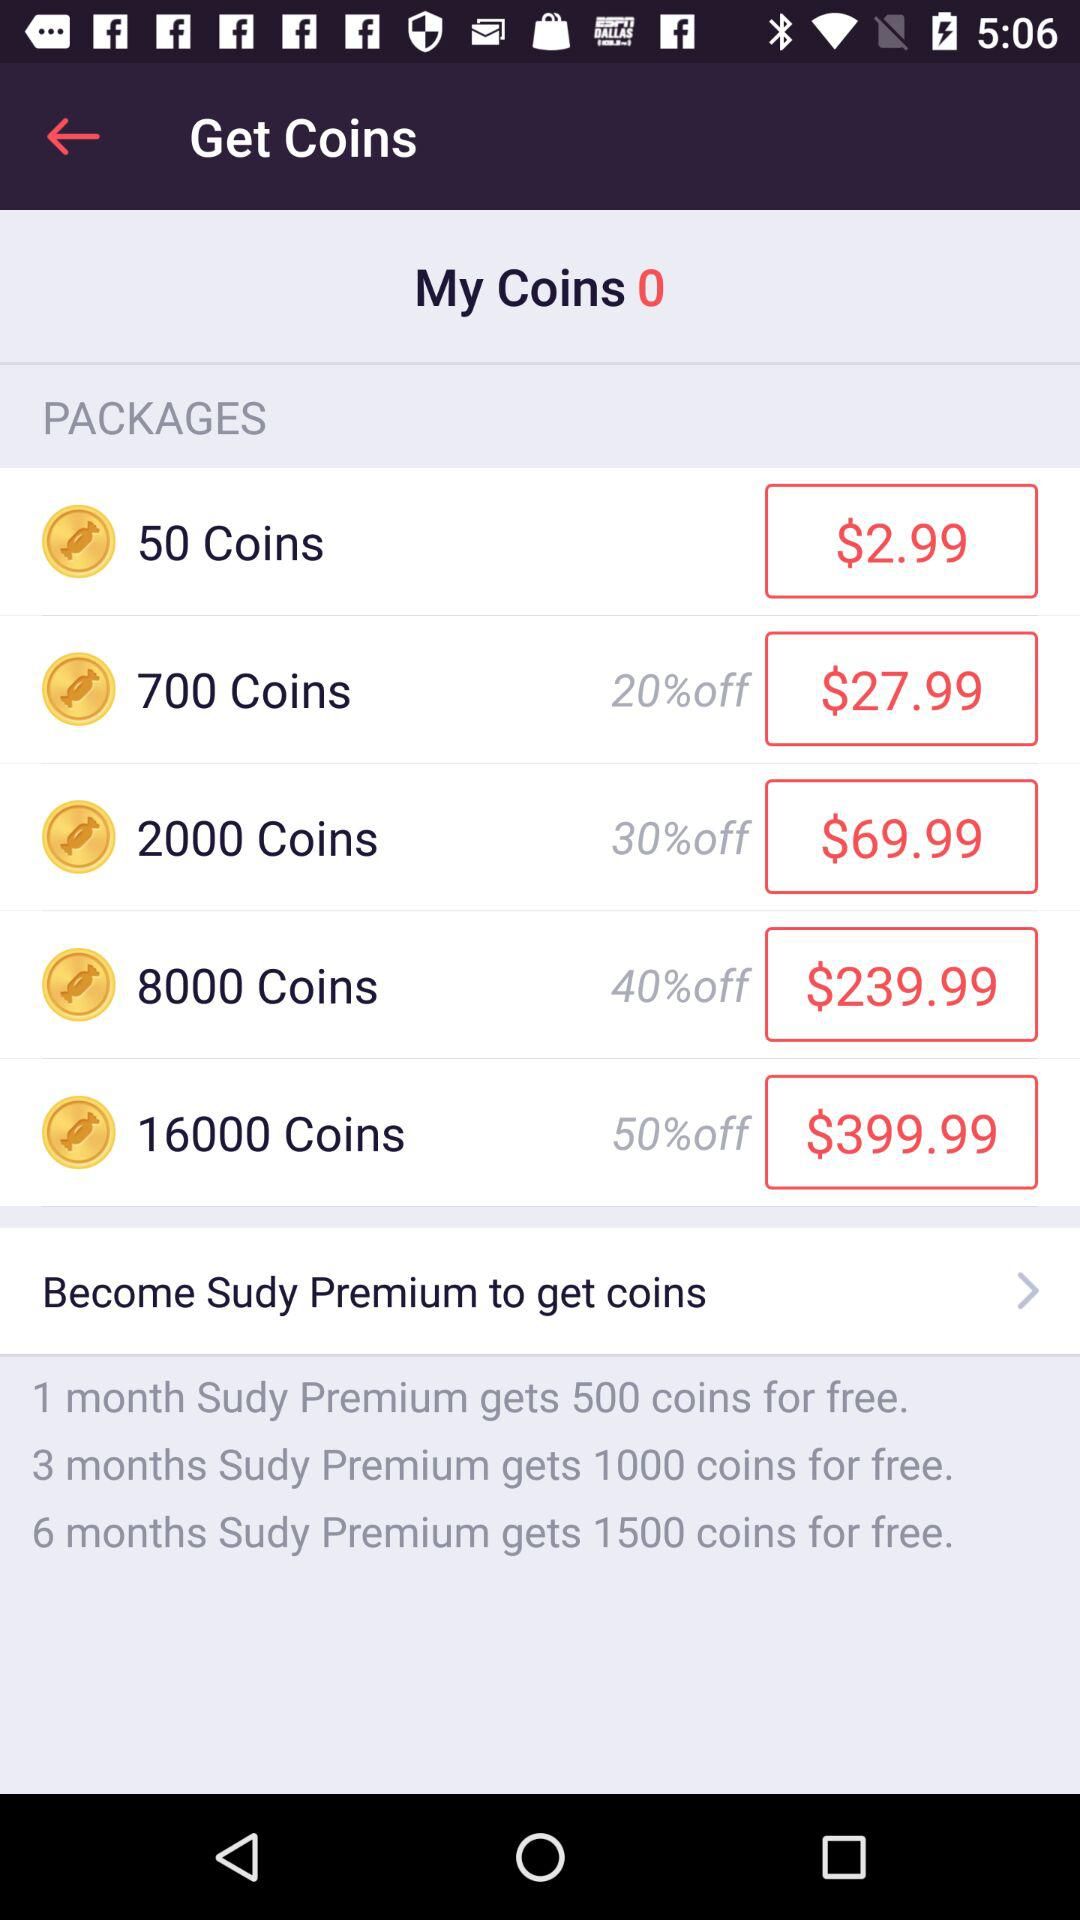How many free coins can we get from a 1 month "Sudy" premium? You can get 500 coins from a 1 month "Sudy" premium. 